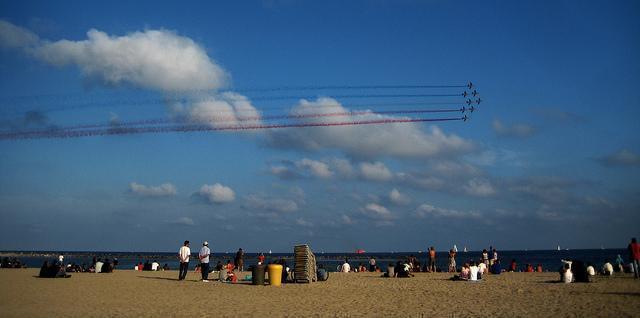How many colors are ejected from the planes flying in formation?
From the following four choices, select the correct answer to address the question.
Options: Four, five, six, seven. Five. 